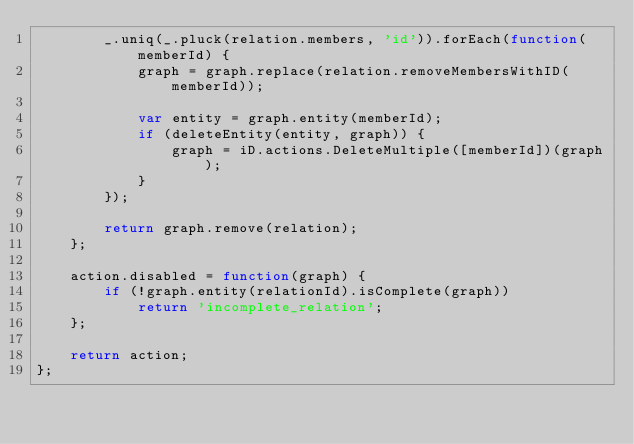Convert code to text. <code><loc_0><loc_0><loc_500><loc_500><_JavaScript_>        _.uniq(_.pluck(relation.members, 'id')).forEach(function(memberId) {
            graph = graph.replace(relation.removeMembersWithID(memberId));

            var entity = graph.entity(memberId);
            if (deleteEntity(entity, graph)) {
                graph = iD.actions.DeleteMultiple([memberId])(graph);
            }
        });

        return graph.remove(relation);
    };

    action.disabled = function(graph) {
        if (!graph.entity(relationId).isComplete(graph))
            return 'incomplete_relation';
    };

    return action;
};
</code> 